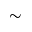Convert formula to latex. <formula><loc_0><loc_0><loc_500><loc_500>\sim</formula> 